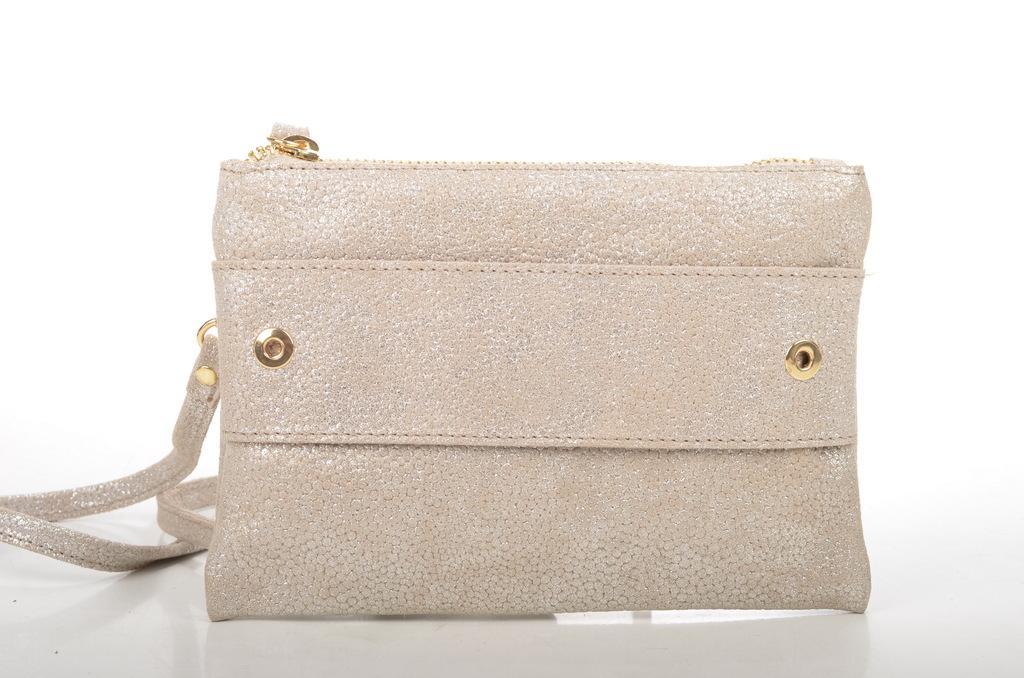Please provide a concise description of this image. This image consists of a bag which is in shiny white color. It has a zip and a handle. 